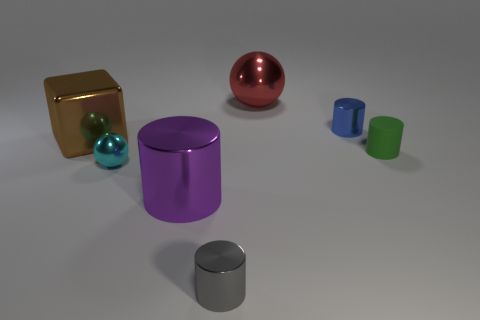Does the brown metallic block have the same size as the cyan metal thing?
Your answer should be compact. No. Is the large object behind the brown cube made of the same material as the tiny green cylinder in front of the blue object?
Keep it short and to the point. No. The big thing that is in front of the ball on the left side of the tiny cylinder that is left of the red shiny ball is what shape?
Ensure brevity in your answer.  Cylinder. Are there more metallic things than tiny blue cylinders?
Provide a short and direct response. Yes. Is there a tiny rubber block?
Your response must be concise. No. What number of objects are cylinders behind the gray shiny cylinder or small shiny objects behind the tiny green cylinder?
Provide a short and direct response. 3. Are there fewer large objects than big yellow balls?
Offer a very short reply. No. Are there any small cylinders to the left of the tiny blue cylinder?
Your answer should be compact. Yes. Does the purple cylinder have the same material as the tiny cyan thing?
Keep it short and to the point. Yes. The tiny matte thing that is the same shape as the small gray metal object is what color?
Make the answer very short. Green. 